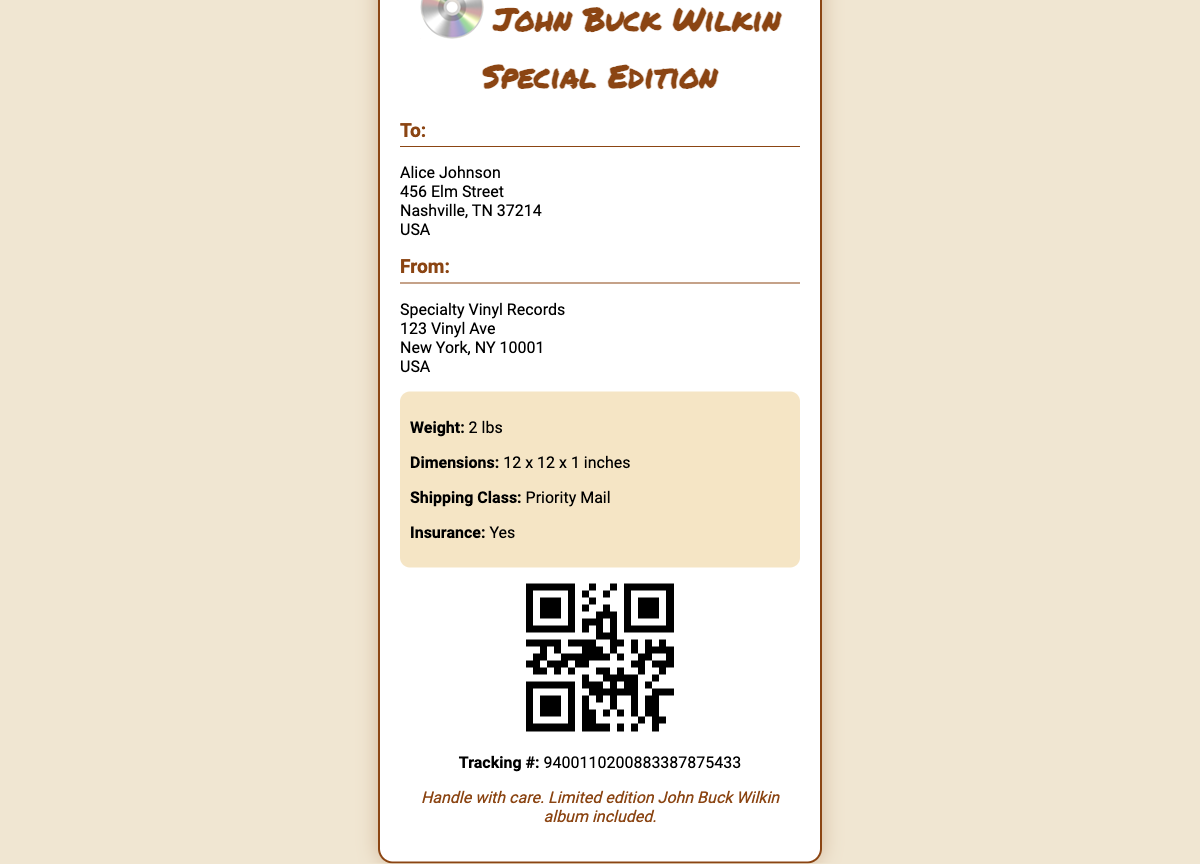What is the recipient's name? The shipping label lists the recipient's name as Alice Johnson.
Answer: Alice Johnson What is the weight of the package? The weight mentioned in the package details section is 2 lbs.
Answer: 2 lbs What is the shipping class? The shipping label specifies "Priority Mail" as the shipping class.
Answer: Priority Mail What is the tracking number? The label provides the tracking number as 9400110200883387875433.
Answer: 9400110200883387875433 What are the dimensions of the package? The dimensions listed are 12 x 12 x 1 inches.
Answer: 12 x 12 x 1 inches Who is the sender of the package? The shipping label shows the sender as Specialty Vinyl Records.
Answer: Specialty Vinyl Records What is the insurance status? The package details indicate that insurance is included.
Answer: Yes What should be noted about the package? The notes section states to "Handle with care."
Answer: Handle with care Which album is being shipped? The header of the shipping label mentions "John Buck Wilkin Special Edition."
Answer: John Buck Wilkin Special Edition 